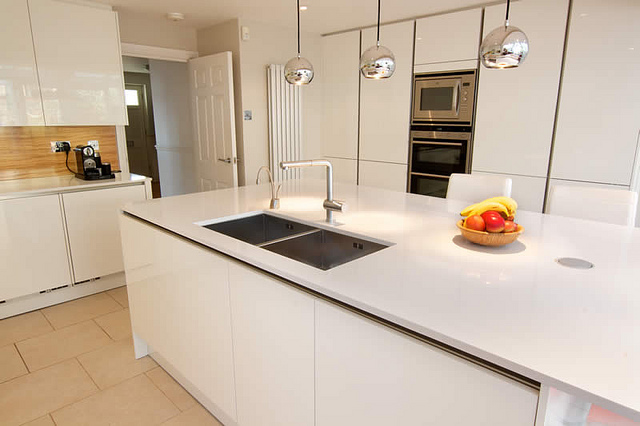<image>Where is the iPod? There is no iPod in the image. However, it can be on the counter or in the bedroom. Where is the iPod? It is unknown where the iPod is located. It is not pictured in the provided information. 